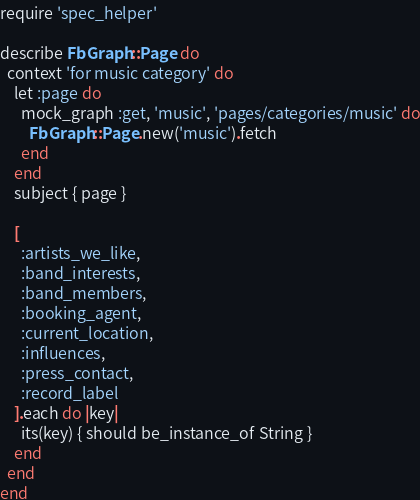<code> <loc_0><loc_0><loc_500><loc_500><_Ruby_>require 'spec_helper'

describe FbGraph::Page do
  context 'for music category' do
    let :page do
      mock_graph :get, 'music', 'pages/categories/music' do
        FbGraph::Page.new('music').fetch
      end
    end
    subject { page }

    [
      :artists_we_like,
      :band_interests,
      :band_members,
      :booking_agent,
      :current_location,
      :influences,
      :press_contact,
      :record_label
    ].each do |key|
      its(key) { should be_instance_of String }
    end
  end
end</code> 